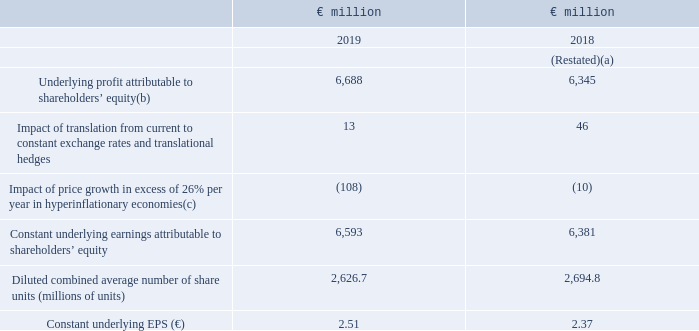Constant underlying earnings per share
Constant underlying earnings per share (constant underlying EPS) is calculated as underlying profit attributable to shareholders’ equity at constant exchange rates and excluding the impact of both translational hedges and price growth in excess of 26% per year in hyperinflationary economies divided by the diluted average number of ordinary share units. This measure reflects the underlying earnings for each ordinary share unit of the Group in constant exchange rates.
The reconciliation of underlying profit attributable to shareholders’ equity to constant underlying earnings attributable to shareholders’ equity and the calculation of constant underlying EPS is as follows:
(a) Restated following adoption of IFRS 16. See note 1 and note 24 for further details.
(b) See note 7.
(c) See pages 28 and 29 for further details.
How is the constant underlying earnings per share calculated? Underlying profit attributable to shareholders’ equity at constant exchange rates and excluding the impact of both translational hedges and price growth in excess of 26% per year in hyperinflationary economies divided by the diluted average number of ordinary share units. What does the constant underlying earnings per share reflect? Underlying earnings for each ordinary share unit of the group in constant exchange rates. What is the EPS in 2019?
Answer scale should be: million. 2.51. What is the percentage increase Underlying profit attributable to shareholders’ equity from 2018 to 2019?
Answer scale should be: percent. 6,688 / 6,345 - 1
Answer: 5.41. What is the change in the Diluted combined average number of share units (millions of units) from 2018 to 2019?
Answer scale should be: million. 2,626.7 - 2,694.8
Answer: -68.1. What is the average Constant underlying earnings attributable to shareholders’ equity?
Answer scale should be: million. (6,593 + 6,381) / 2
Answer: 6487. 